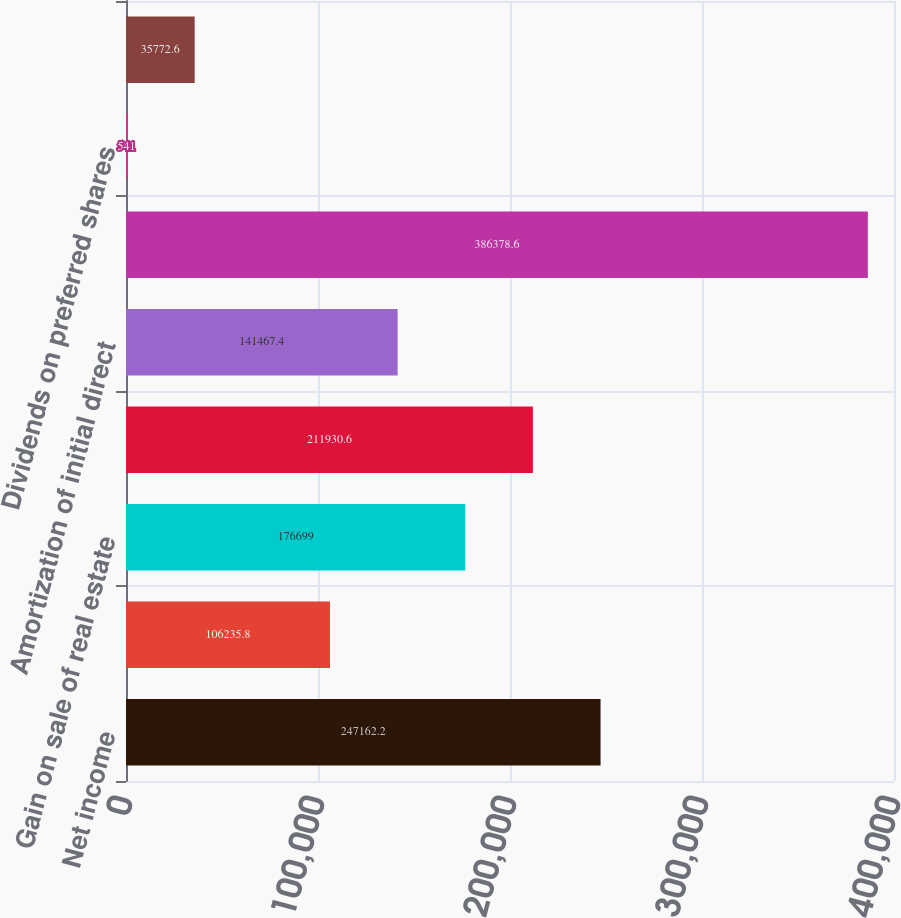Convert chart to OTSL. <chart><loc_0><loc_0><loc_500><loc_500><bar_chart><fcel>Net income<fcel>Net income attributable to<fcel>Gain on sale of real estate<fcel>Depreciation and amortization<fcel>Amortization of initial direct<fcel>Funds from operations<fcel>Dividends on preferred shares<fcel>Income attributable to<nl><fcel>247162<fcel>106236<fcel>176699<fcel>211931<fcel>141467<fcel>386379<fcel>541<fcel>35772.6<nl></chart> 